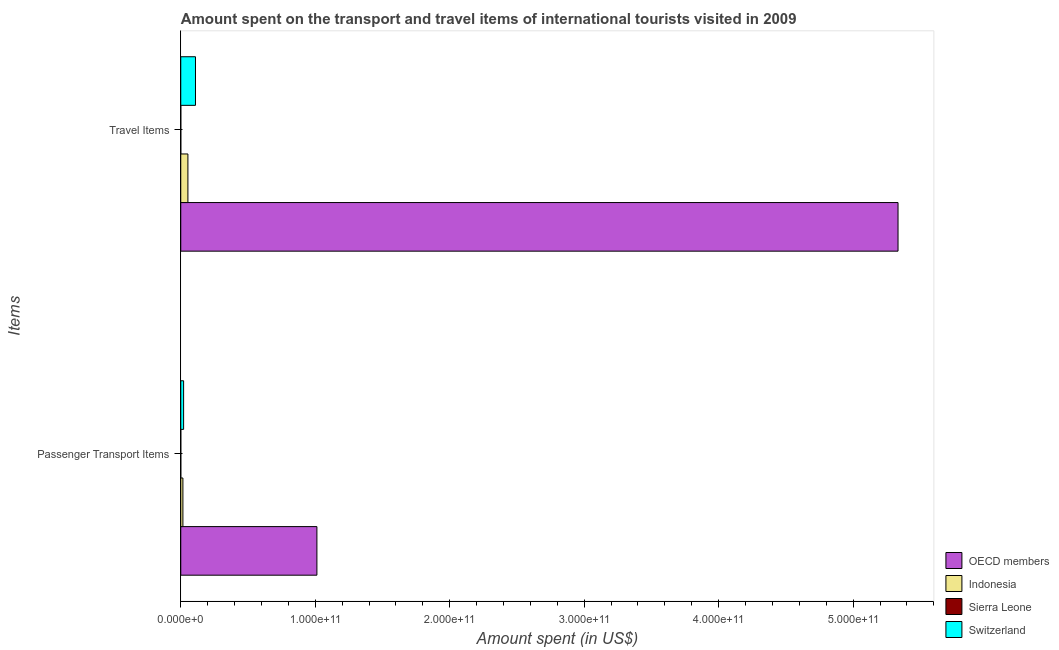Are the number of bars per tick equal to the number of legend labels?
Your answer should be very brief. Yes. Are the number of bars on each tick of the Y-axis equal?
Make the answer very short. Yes. How many bars are there on the 1st tick from the top?
Ensure brevity in your answer.  4. How many bars are there on the 2nd tick from the bottom?
Your response must be concise. 4. What is the label of the 1st group of bars from the top?
Provide a succinct answer. Travel Items. What is the amount spent on passenger transport items in Indonesia?
Your response must be concise. 1.59e+09. Across all countries, what is the maximum amount spent on passenger transport items?
Keep it short and to the point. 1.01e+11. Across all countries, what is the minimum amount spent in travel items?
Your answer should be very brief. 1.30e+07. In which country was the amount spent in travel items maximum?
Your answer should be compact. OECD members. In which country was the amount spent on passenger transport items minimum?
Your response must be concise. Sierra Leone. What is the total amount spent on passenger transport items in the graph?
Keep it short and to the point. 1.05e+11. What is the difference between the amount spent in travel items in OECD members and that in Indonesia?
Provide a succinct answer. 5.28e+11. What is the difference between the amount spent on passenger transport items in OECD members and the amount spent in travel items in Switzerland?
Offer a terse response. 9.03e+1. What is the average amount spent in travel items per country?
Your response must be concise. 1.37e+11. What is the difference between the amount spent in travel items and amount spent on passenger transport items in OECD members?
Offer a terse response. 4.32e+11. In how many countries, is the amount spent in travel items greater than 60000000000 US$?
Make the answer very short. 1. What is the ratio of the amount spent in travel items in Switzerland to that in OECD members?
Keep it short and to the point. 0.02. In how many countries, is the amount spent on passenger transport items greater than the average amount spent on passenger transport items taken over all countries?
Your answer should be compact. 1. What does the 1st bar from the top in Travel Items represents?
Make the answer very short. Switzerland. How many countries are there in the graph?
Your answer should be compact. 4. What is the difference between two consecutive major ticks on the X-axis?
Provide a short and direct response. 1.00e+11. Are the values on the major ticks of X-axis written in scientific E-notation?
Ensure brevity in your answer.  Yes. Does the graph contain any zero values?
Your response must be concise. No. Where does the legend appear in the graph?
Provide a short and direct response. Bottom right. How many legend labels are there?
Your answer should be very brief. 4. What is the title of the graph?
Your answer should be very brief. Amount spent on the transport and travel items of international tourists visited in 2009. What is the label or title of the X-axis?
Your answer should be compact. Amount spent (in US$). What is the label or title of the Y-axis?
Offer a terse response. Items. What is the Amount spent (in US$) of OECD members in Passenger Transport Items?
Provide a short and direct response. 1.01e+11. What is the Amount spent (in US$) in Indonesia in Passenger Transport Items?
Make the answer very short. 1.59e+09. What is the Amount spent (in US$) in Sierra Leone in Passenger Transport Items?
Offer a very short reply. 1.30e+07. What is the Amount spent (in US$) in Switzerland in Passenger Transport Items?
Your answer should be compact. 2.11e+09. What is the Amount spent (in US$) in OECD members in Travel Items?
Offer a terse response. 5.33e+11. What is the Amount spent (in US$) in Indonesia in Travel Items?
Make the answer very short. 5.32e+09. What is the Amount spent (in US$) of Sierra Leone in Travel Items?
Offer a terse response. 1.30e+07. What is the Amount spent (in US$) in Switzerland in Travel Items?
Your response must be concise. 1.09e+1. Across all Items, what is the maximum Amount spent (in US$) in OECD members?
Keep it short and to the point. 5.33e+11. Across all Items, what is the maximum Amount spent (in US$) of Indonesia?
Ensure brevity in your answer.  5.32e+09. Across all Items, what is the maximum Amount spent (in US$) of Sierra Leone?
Your answer should be compact. 1.30e+07. Across all Items, what is the maximum Amount spent (in US$) of Switzerland?
Your response must be concise. 1.09e+1. Across all Items, what is the minimum Amount spent (in US$) in OECD members?
Your answer should be compact. 1.01e+11. Across all Items, what is the minimum Amount spent (in US$) in Indonesia?
Your response must be concise. 1.59e+09. Across all Items, what is the minimum Amount spent (in US$) of Sierra Leone?
Ensure brevity in your answer.  1.30e+07. Across all Items, what is the minimum Amount spent (in US$) in Switzerland?
Offer a very short reply. 2.11e+09. What is the total Amount spent (in US$) in OECD members in the graph?
Offer a very short reply. 6.35e+11. What is the total Amount spent (in US$) of Indonesia in the graph?
Offer a terse response. 6.91e+09. What is the total Amount spent (in US$) in Sierra Leone in the graph?
Give a very brief answer. 2.60e+07. What is the total Amount spent (in US$) in Switzerland in the graph?
Your response must be concise. 1.31e+1. What is the difference between the Amount spent (in US$) in OECD members in Passenger Transport Items and that in Travel Items?
Offer a terse response. -4.32e+11. What is the difference between the Amount spent (in US$) of Indonesia in Passenger Transport Items and that in Travel Items?
Your response must be concise. -3.72e+09. What is the difference between the Amount spent (in US$) of Switzerland in Passenger Transport Items and that in Travel Items?
Your answer should be compact. -8.84e+09. What is the difference between the Amount spent (in US$) in OECD members in Passenger Transport Items and the Amount spent (in US$) in Indonesia in Travel Items?
Your response must be concise. 9.59e+1. What is the difference between the Amount spent (in US$) of OECD members in Passenger Transport Items and the Amount spent (in US$) of Sierra Leone in Travel Items?
Ensure brevity in your answer.  1.01e+11. What is the difference between the Amount spent (in US$) of OECD members in Passenger Transport Items and the Amount spent (in US$) of Switzerland in Travel Items?
Make the answer very short. 9.03e+1. What is the difference between the Amount spent (in US$) of Indonesia in Passenger Transport Items and the Amount spent (in US$) of Sierra Leone in Travel Items?
Provide a succinct answer. 1.58e+09. What is the difference between the Amount spent (in US$) of Indonesia in Passenger Transport Items and the Amount spent (in US$) of Switzerland in Travel Items?
Your answer should be very brief. -9.36e+09. What is the difference between the Amount spent (in US$) in Sierra Leone in Passenger Transport Items and the Amount spent (in US$) in Switzerland in Travel Items?
Provide a succinct answer. -1.09e+1. What is the average Amount spent (in US$) of OECD members per Items?
Keep it short and to the point. 3.17e+11. What is the average Amount spent (in US$) of Indonesia per Items?
Ensure brevity in your answer.  3.45e+09. What is the average Amount spent (in US$) in Sierra Leone per Items?
Ensure brevity in your answer.  1.30e+07. What is the average Amount spent (in US$) of Switzerland per Items?
Ensure brevity in your answer.  6.53e+09. What is the difference between the Amount spent (in US$) in OECD members and Amount spent (in US$) in Indonesia in Passenger Transport Items?
Your answer should be very brief. 9.96e+1. What is the difference between the Amount spent (in US$) in OECD members and Amount spent (in US$) in Sierra Leone in Passenger Transport Items?
Offer a very short reply. 1.01e+11. What is the difference between the Amount spent (in US$) of OECD members and Amount spent (in US$) of Switzerland in Passenger Transport Items?
Your answer should be compact. 9.91e+1. What is the difference between the Amount spent (in US$) in Indonesia and Amount spent (in US$) in Sierra Leone in Passenger Transport Items?
Provide a succinct answer. 1.58e+09. What is the difference between the Amount spent (in US$) in Indonesia and Amount spent (in US$) in Switzerland in Passenger Transport Items?
Offer a very short reply. -5.18e+08. What is the difference between the Amount spent (in US$) of Sierra Leone and Amount spent (in US$) of Switzerland in Passenger Transport Items?
Your answer should be very brief. -2.10e+09. What is the difference between the Amount spent (in US$) in OECD members and Amount spent (in US$) in Indonesia in Travel Items?
Your answer should be very brief. 5.28e+11. What is the difference between the Amount spent (in US$) in OECD members and Amount spent (in US$) in Sierra Leone in Travel Items?
Offer a terse response. 5.33e+11. What is the difference between the Amount spent (in US$) in OECD members and Amount spent (in US$) in Switzerland in Travel Items?
Ensure brevity in your answer.  5.22e+11. What is the difference between the Amount spent (in US$) in Indonesia and Amount spent (in US$) in Sierra Leone in Travel Items?
Your answer should be very brief. 5.30e+09. What is the difference between the Amount spent (in US$) in Indonesia and Amount spent (in US$) in Switzerland in Travel Items?
Offer a very short reply. -5.63e+09. What is the difference between the Amount spent (in US$) of Sierra Leone and Amount spent (in US$) of Switzerland in Travel Items?
Keep it short and to the point. -1.09e+1. What is the ratio of the Amount spent (in US$) of OECD members in Passenger Transport Items to that in Travel Items?
Offer a very short reply. 0.19. What is the ratio of the Amount spent (in US$) of Indonesia in Passenger Transport Items to that in Travel Items?
Make the answer very short. 0.3. What is the ratio of the Amount spent (in US$) in Switzerland in Passenger Transport Items to that in Travel Items?
Your response must be concise. 0.19. What is the difference between the highest and the second highest Amount spent (in US$) in OECD members?
Provide a short and direct response. 4.32e+11. What is the difference between the highest and the second highest Amount spent (in US$) in Indonesia?
Make the answer very short. 3.72e+09. What is the difference between the highest and the second highest Amount spent (in US$) of Sierra Leone?
Make the answer very short. 0. What is the difference between the highest and the second highest Amount spent (in US$) of Switzerland?
Your answer should be compact. 8.84e+09. What is the difference between the highest and the lowest Amount spent (in US$) of OECD members?
Provide a short and direct response. 4.32e+11. What is the difference between the highest and the lowest Amount spent (in US$) in Indonesia?
Your answer should be very brief. 3.72e+09. What is the difference between the highest and the lowest Amount spent (in US$) in Sierra Leone?
Ensure brevity in your answer.  0. What is the difference between the highest and the lowest Amount spent (in US$) of Switzerland?
Keep it short and to the point. 8.84e+09. 